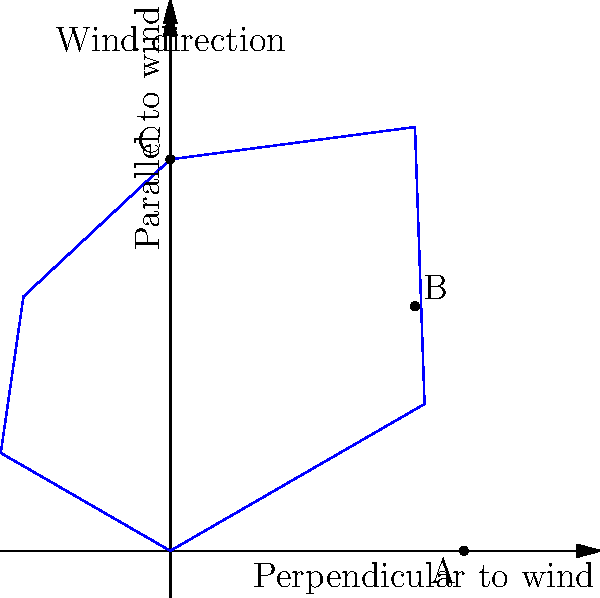Based on the polar diagram shown, which point (A, B, or C) represents the optimal sailing angle for maximum boat speed relative to the wind direction? To determine the optimal sailing angle for maximum boat speed, we need to analyze the polar diagram:

1. The polar diagram shows boat speed at different angles relative to the wind direction.
2. The wind direction is indicated by the arrow pointing upwards.
3. The distance from the center represents the boat's speed.
4. We need to find the point furthest from the center, which indicates the highest speed.

Let's examine each point:

A: Located on the x-axis, representing sailing perpendicular to the wind (beam reach).
B: Located at approximately 45 degrees to the wind (broad reach).
C: Located on the y-axis, representing sailing directly downwind.

Point B is clearly the furthest from the center, indicating the highest boat speed.

This makes sense because:
- Sailing directly into the wind (0 degrees) or directly downwind (180 degrees) is generally slower.
- The optimal angle is usually between 90 and 150 degrees to the wind, which is where point B is located.

Therefore, point B represents the optimal sailing angle for maximum boat speed relative to the wind direction.
Answer: B 